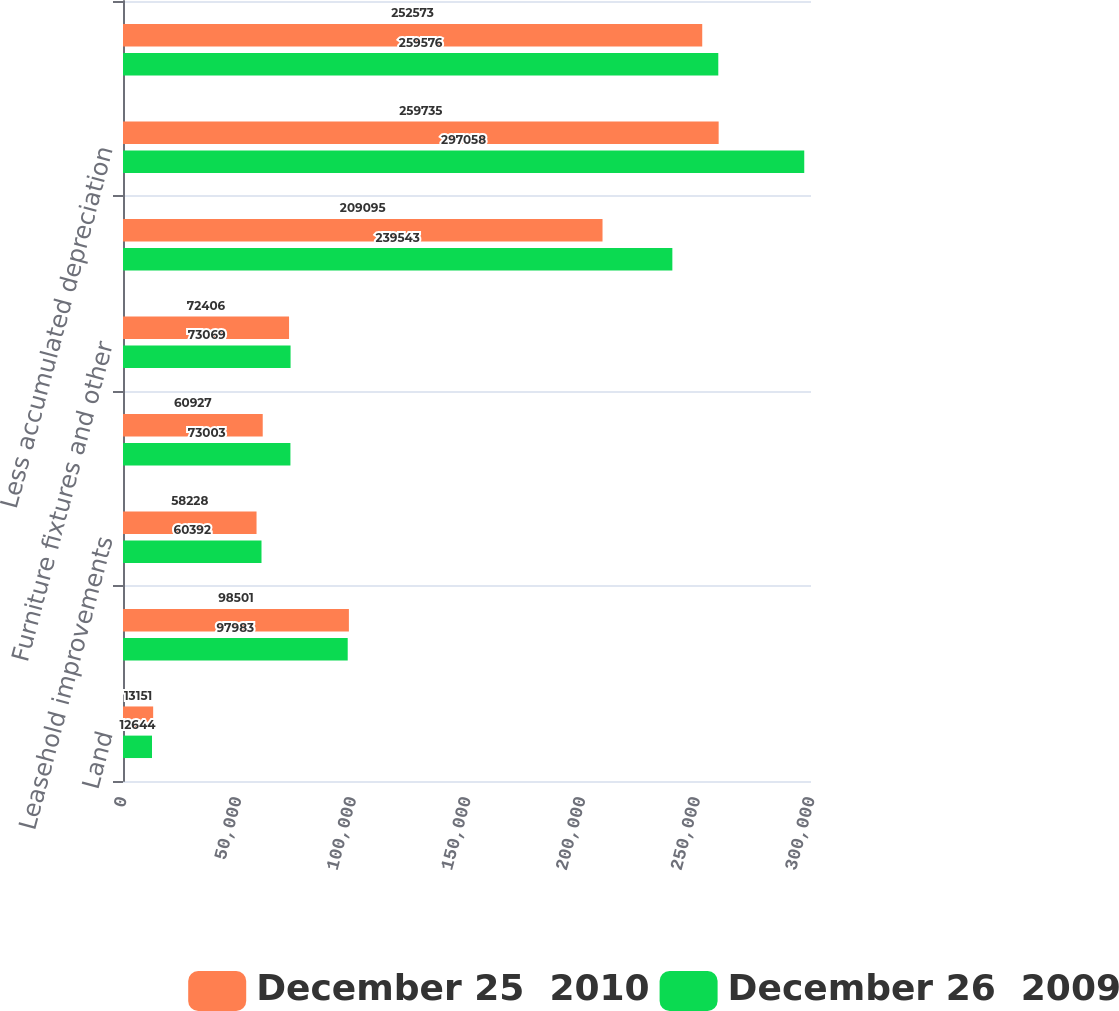Convert chart. <chart><loc_0><loc_0><loc_500><loc_500><stacked_bar_chart><ecel><fcel>Land<fcel>Buildings and permanent<fcel>Leasehold improvements<fcel>Machinery and warehouse<fcel>Furniture fixtures and other<fcel>Computer equipment and<fcel>Less accumulated depreciation<fcel>Property and equipment net<nl><fcel>December 25  2010<fcel>13151<fcel>98501<fcel>58228<fcel>60927<fcel>72406<fcel>209095<fcel>259735<fcel>252573<nl><fcel>December 26  2009<fcel>12644<fcel>97983<fcel>60392<fcel>73003<fcel>73069<fcel>239543<fcel>297058<fcel>259576<nl></chart> 